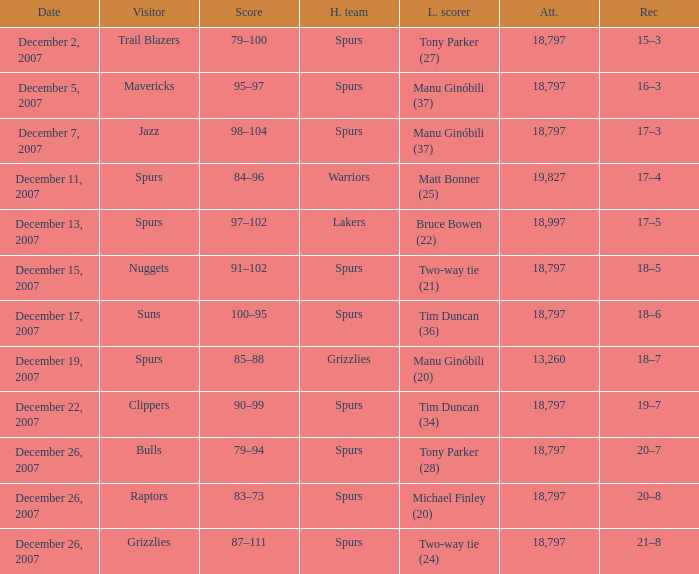What is the highest attendace of the game with the Lakers as the home team? 18997.0. 